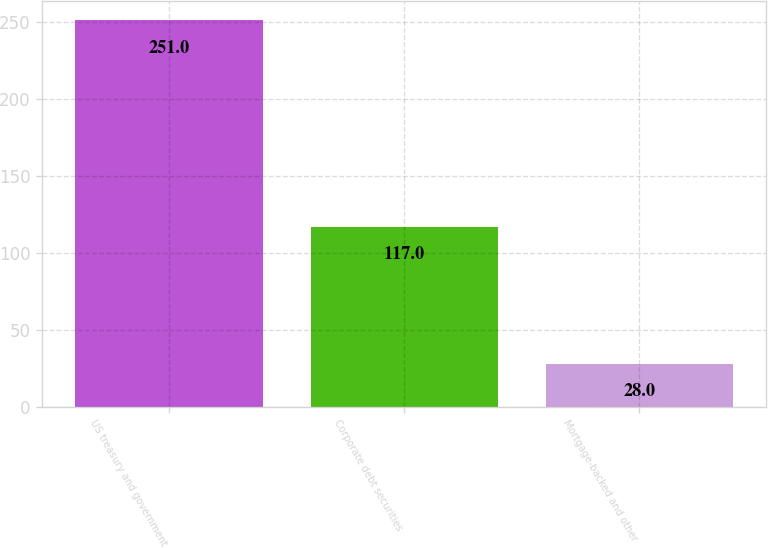Convert chart. <chart><loc_0><loc_0><loc_500><loc_500><bar_chart><fcel>US treasury and government<fcel>Corporate debt securities<fcel>Mortgage-backed and other<nl><fcel>251<fcel>117<fcel>28<nl></chart> 